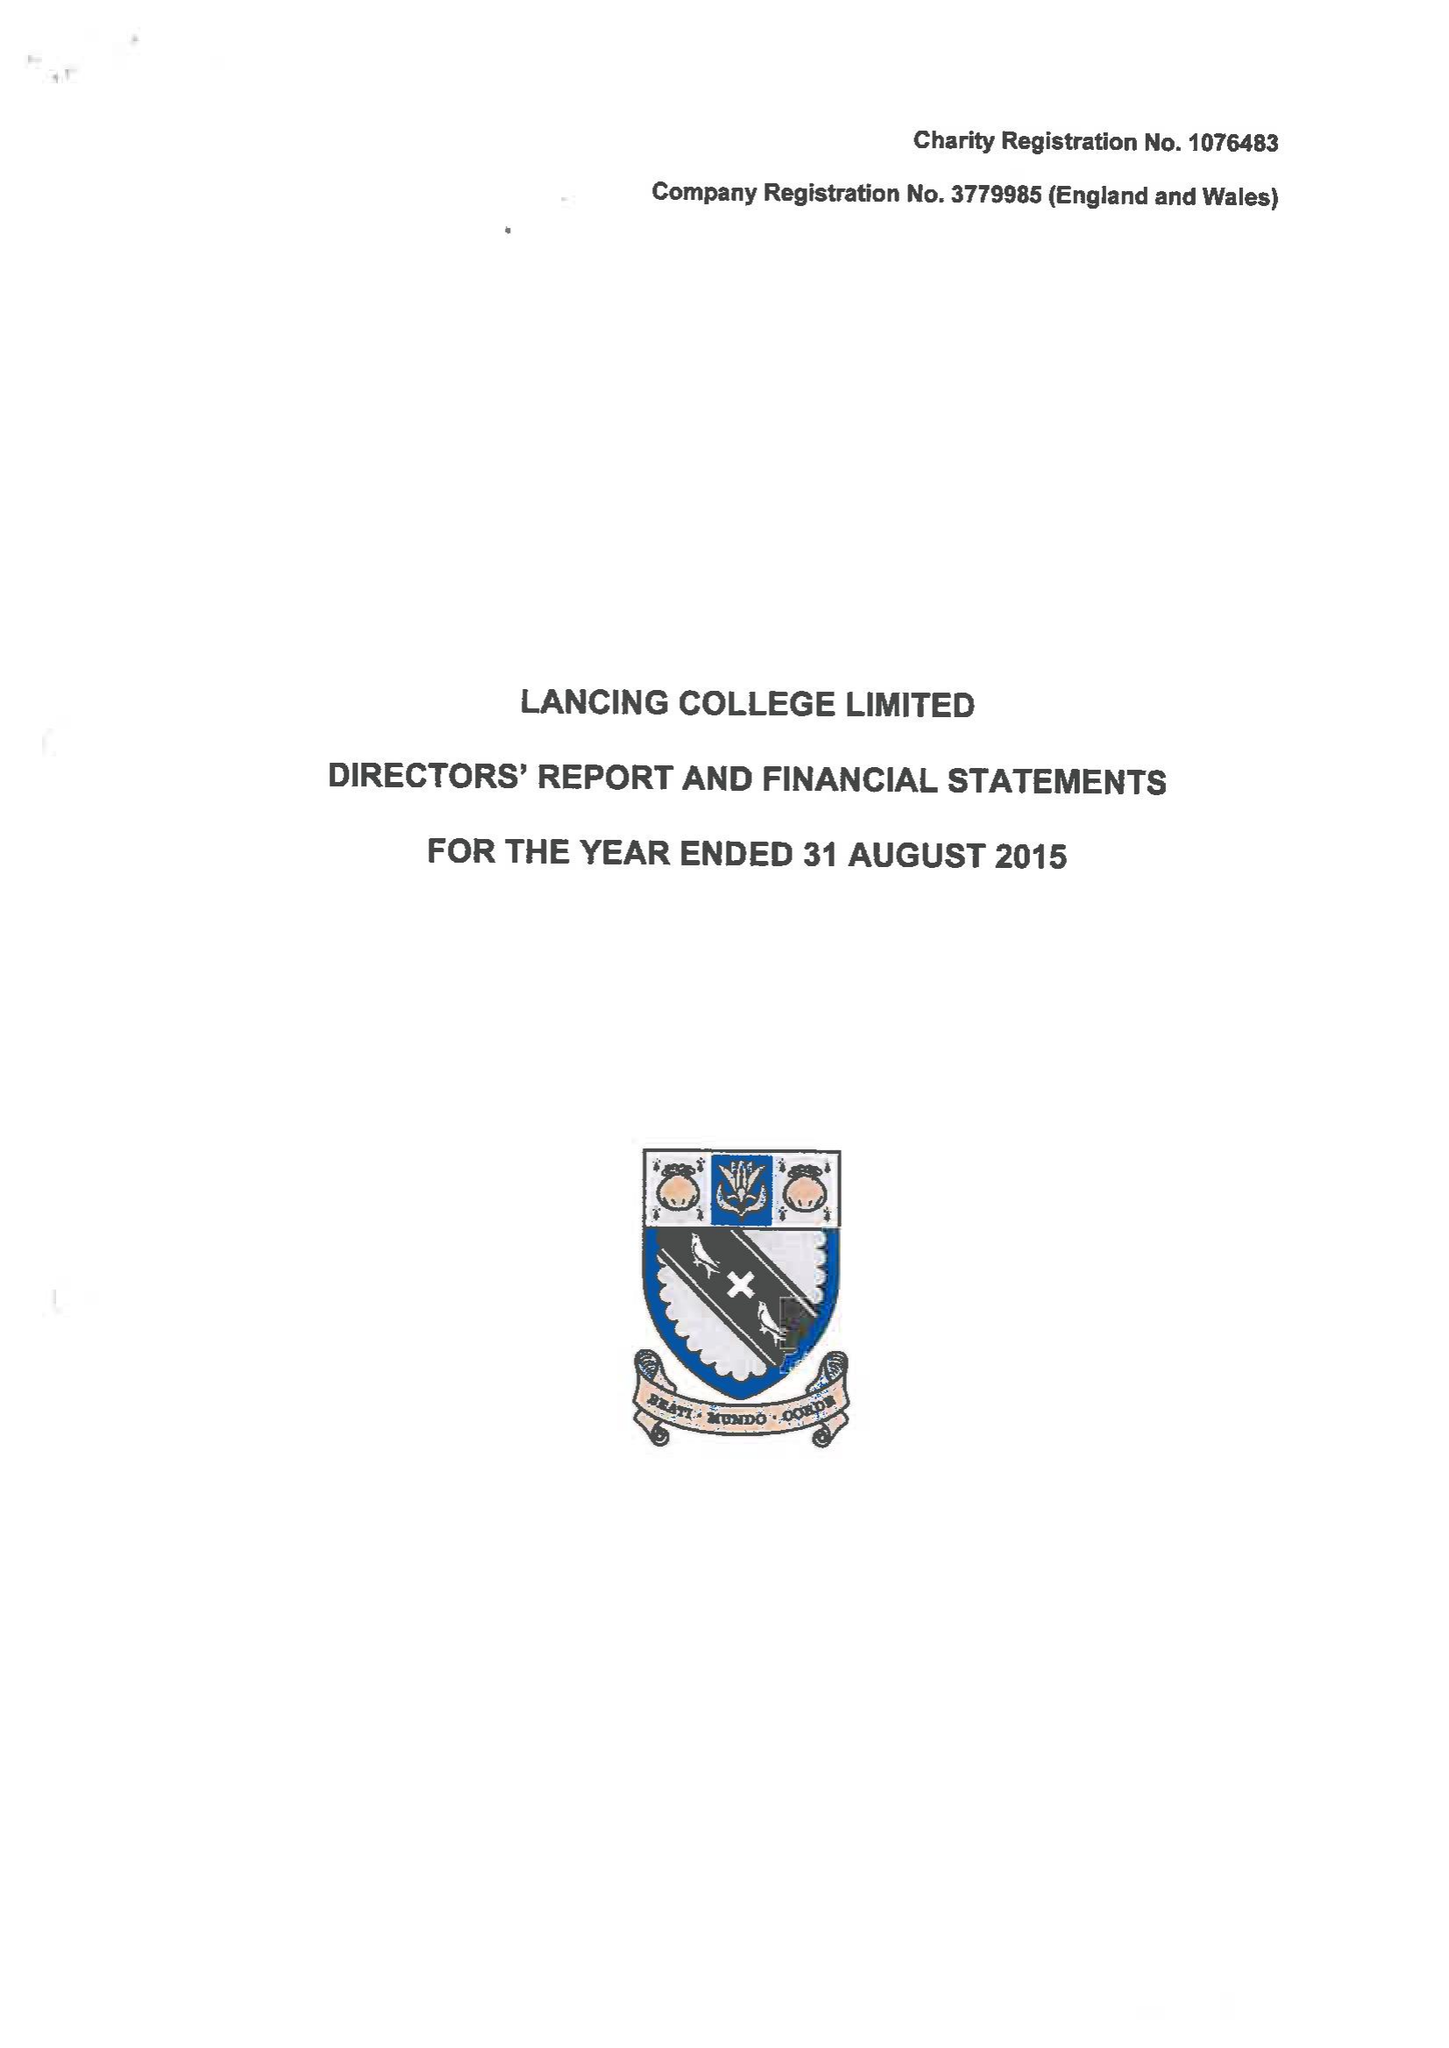What is the value for the charity_name?
Answer the question using a single word or phrase. Lancing College Ltd. 